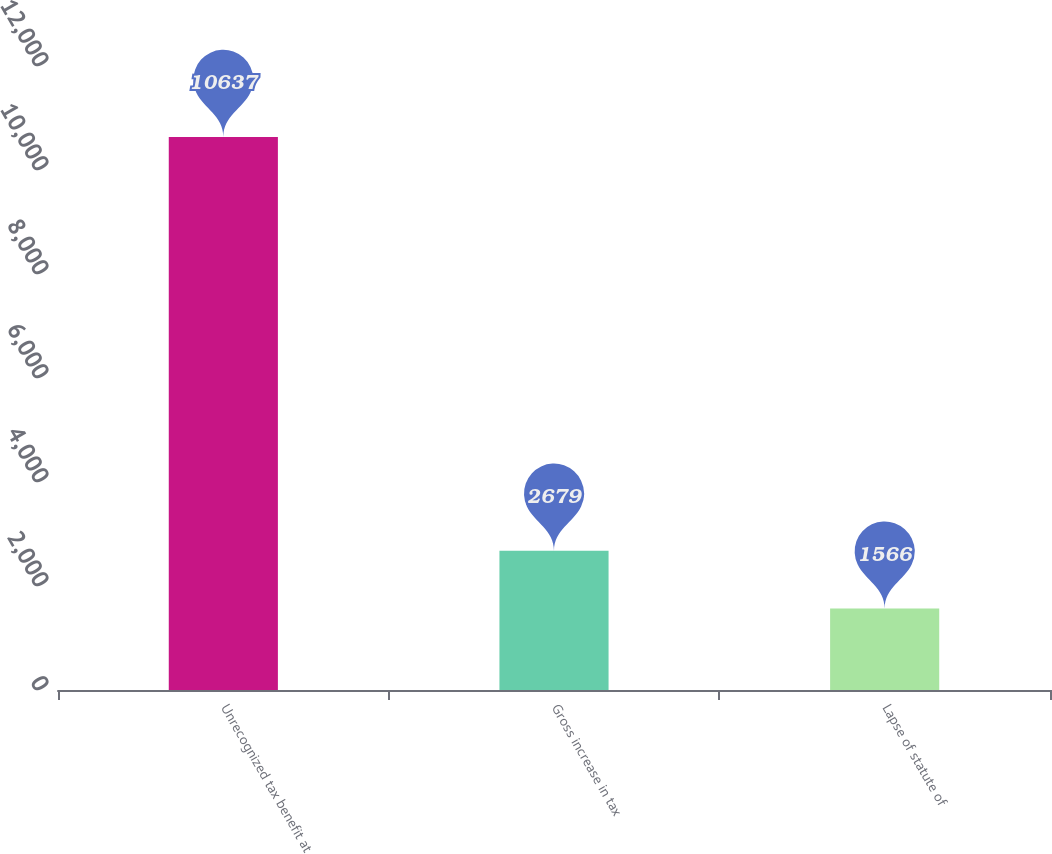Convert chart. <chart><loc_0><loc_0><loc_500><loc_500><bar_chart><fcel>Unrecognized tax benefit at<fcel>Gross increase in tax<fcel>Lapse of statute of<nl><fcel>10637<fcel>2679<fcel>1566<nl></chart> 